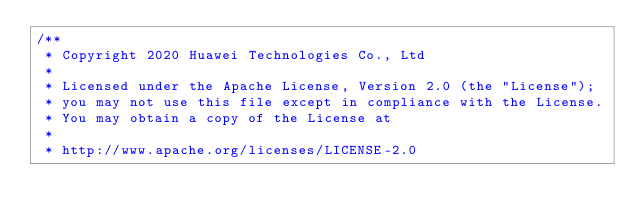Convert code to text. <code><loc_0><loc_0><loc_500><loc_500><_C++_>/**
 * Copyright 2020 Huawei Technologies Co., Ltd
 *
 * Licensed under the Apache License, Version 2.0 (the "License");
 * you may not use this file except in compliance with the License.
 * You may obtain a copy of the License at
 *
 * http://www.apache.org/licenses/LICENSE-2.0</code> 